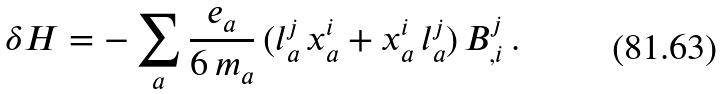<formula> <loc_0><loc_0><loc_500><loc_500>\delta H = - \sum _ { a } \frac { e _ { a } } { 6 \, m _ { a } } \, ( l _ { a } ^ { j } \, x _ { a } ^ { i } + x _ { a } ^ { i } \, l _ { a } ^ { j } ) \, B ^ { j } _ { , i } \, .</formula> 